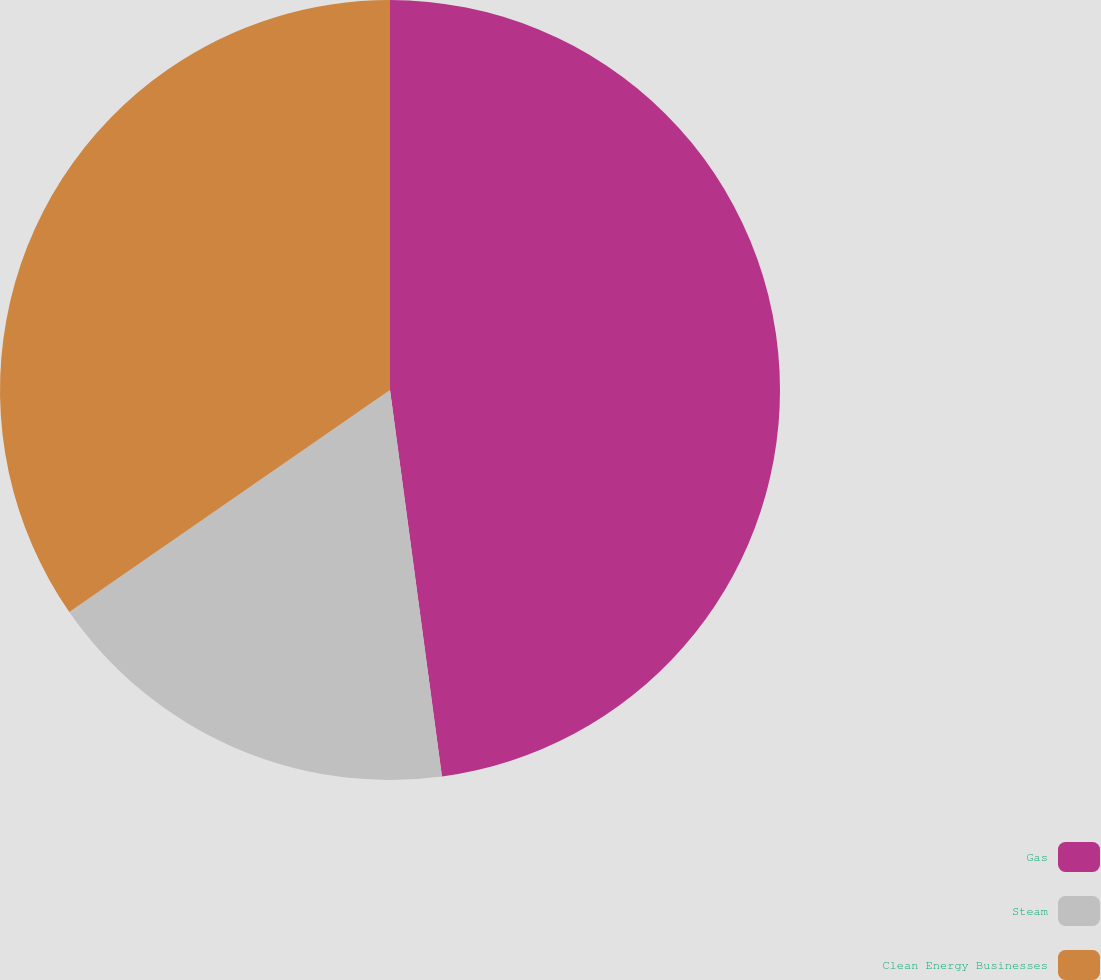Convert chart. <chart><loc_0><loc_0><loc_500><loc_500><pie_chart><fcel>Gas<fcel>Steam<fcel>Clean Energy Businesses<nl><fcel>47.87%<fcel>17.49%<fcel>34.63%<nl></chart> 